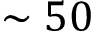Convert formula to latex. <formula><loc_0><loc_0><loc_500><loc_500>\sim 5 0</formula> 